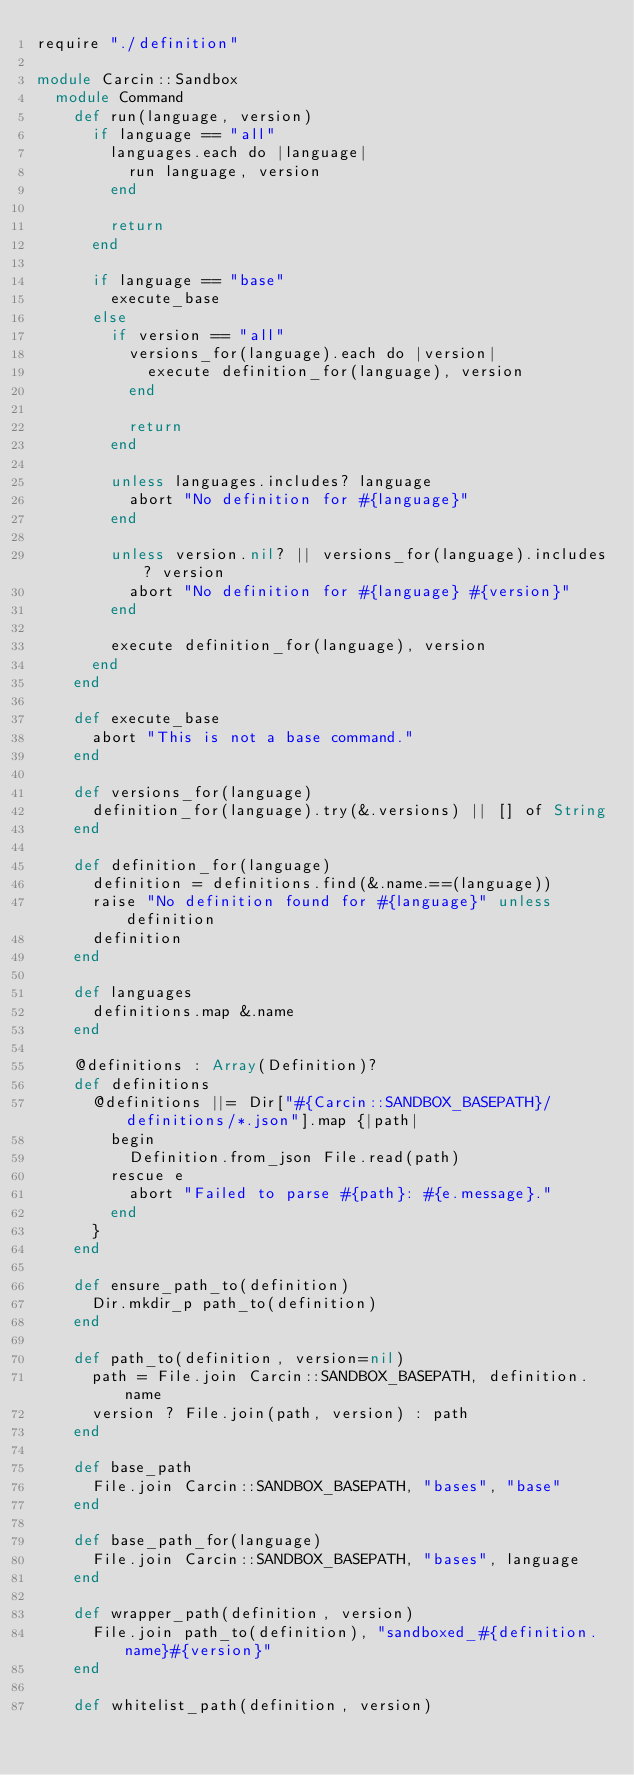<code> <loc_0><loc_0><loc_500><loc_500><_Crystal_>require "./definition"

module Carcin::Sandbox
  module Command
    def run(language, version)
      if language == "all"
        languages.each do |language|
          run language, version
        end

        return
      end

      if language == "base"
        execute_base
      else
        if version == "all"
          versions_for(language).each do |version|
            execute definition_for(language), version
          end

          return
        end

        unless languages.includes? language
          abort "No definition for #{language}"
        end

        unless version.nil? || versions_for(language).includes? version
          abort "No definition for #{language} #{version}"
        end

        execute definition_for(language), version
      end
    end

    def execute_base
      abort "This is not a base command."
    end

    def versions_for(language)
      definition_for(language).try(&.versions) || [] of String
    end

    def definition_for(language)
      definition = definitions.find(&.name.==(language))
      raise "No definition found for #{language}" unless definition
      definition
    end

    def languages
      definitions.map &.name
    end

    @definitions : Array(Definition)?
    def definitions
      @definitions ||= Dir["#{Carcin::SANDBOX_BASEPATH}/definitions/*.json"].map {|path|
        begin
          Definition.from_json File.read(path)
        rescue e
          abort "Failed to parse #{path}: #{e.message}."
        end
      }
    end

    def ensure_path_to(definition)
      Dir.mkdir_p path_to(definition)
    end

    def path_to(definition, version=nil)
      path = File.join Carcin::SANDBOX_BASEPATH, definition.name
      version ? File.join(path, version) : path
    end

    def base_path
      File.join Carcin::SANDBOX_BASEPATH, "bases", "base"
    end

    def base_path_for(language)
      File.join Carcin::SANDBOX_BASEPATH, "bases", language
    end

    def wrapper_path(definition, version)
      File.join path_to(definition), "sandboxed_#{definition.name}#{version}"
    end

    def whitelist_path(definition, version)</code> 